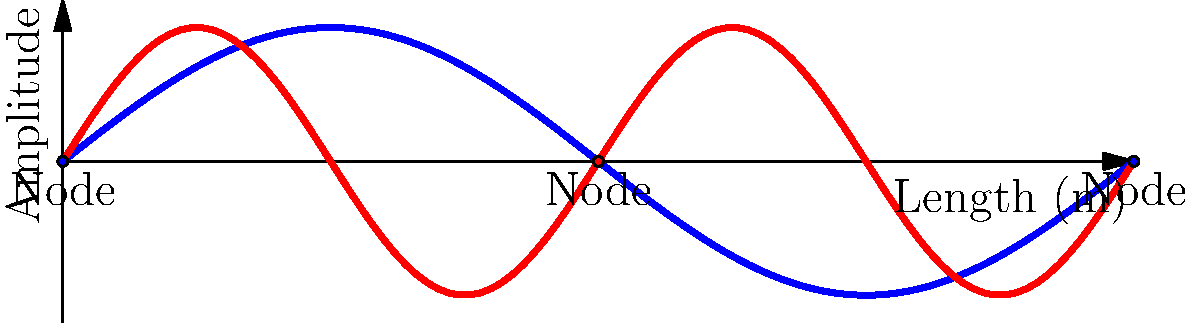As a musician exploring the physics of your instrument, you're analyzing standing waves in guitar strings. The diagram shows the fundamental frequency (blue) and first overtone (red) of a vibrating string. If the fundamental frequency of this string is 220 Hz, what is the frequency of the first overtone? To solve this problem, let's follow these steps:

1. Understand the relationship between harmonics:
   - The fundamental frequency (1st harmonic) is the lowest frequency at which the string vibrates.
   - The first overtone (2nd harmonic) is the next possible standing wave pattern.

2. Observe the wave patterns in the diagram:
   - The fundamental (blue) has nodes only at the ends of the string.
   - The first overtone (red) has an additional node in the middle of the string.

3. Recall the relationship between frequency and wavelength:
   - Frequency is inversely proportional to wavelength: $f = \frac{v}{\lambda}$
   - Where $v$ is the wave velocity and $\lambda$ is the wavelength.

4. Compare the wavelengths:
   - The fundamental's wavelength is twice the length of the string.
   - The first overtone's wavelength is equal to the length of the string.
   - Therefore, the wavelength of the first overtone is half that of the fundamental.

5. Apply the frequency-wavelength relationship:
   - If the wavelength is halved, the frequency must double.
   - First overtone frequency = 2 × Fundamental frequency
   - First overtone frequency = 2 × 220 Hz = 440 Hz

Therefore, the frequency of the first overtone is 440 Hz.
Answer: 440 Hz 